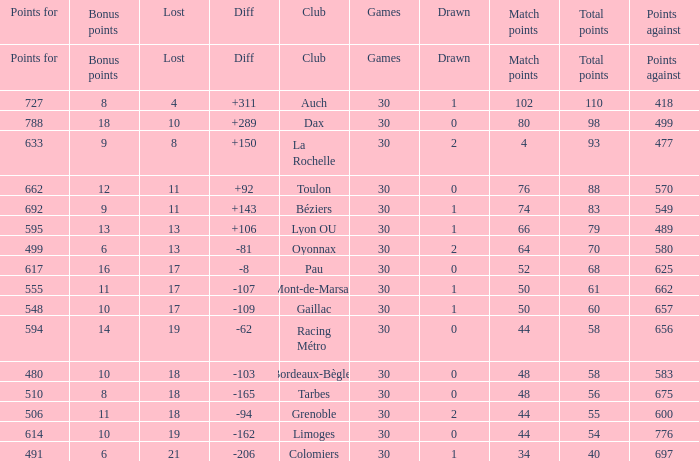What is the diff for a club that has a value of 662 for points for? 92.0. 